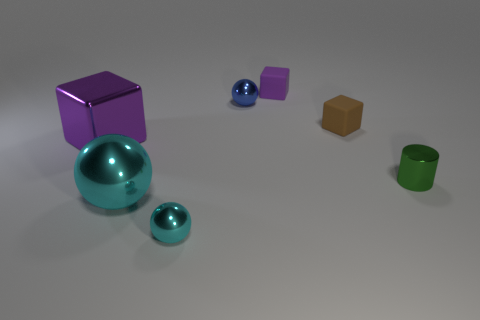Add 2 purple shiny cubes. How many objects exist? 9 Subtract all balls. How many objects are left? 4 Add 6 tiny purple matte things. How many tiny purple matte things are left? 7 Add 6 big cyan metallic objects. How many big cyan metallic objects exist? 7 Subtract 0 gray cylinders. How many objects are left? 7 Subtract all green rubber objects. Subtract all small brown things. How many objects are left? 6 